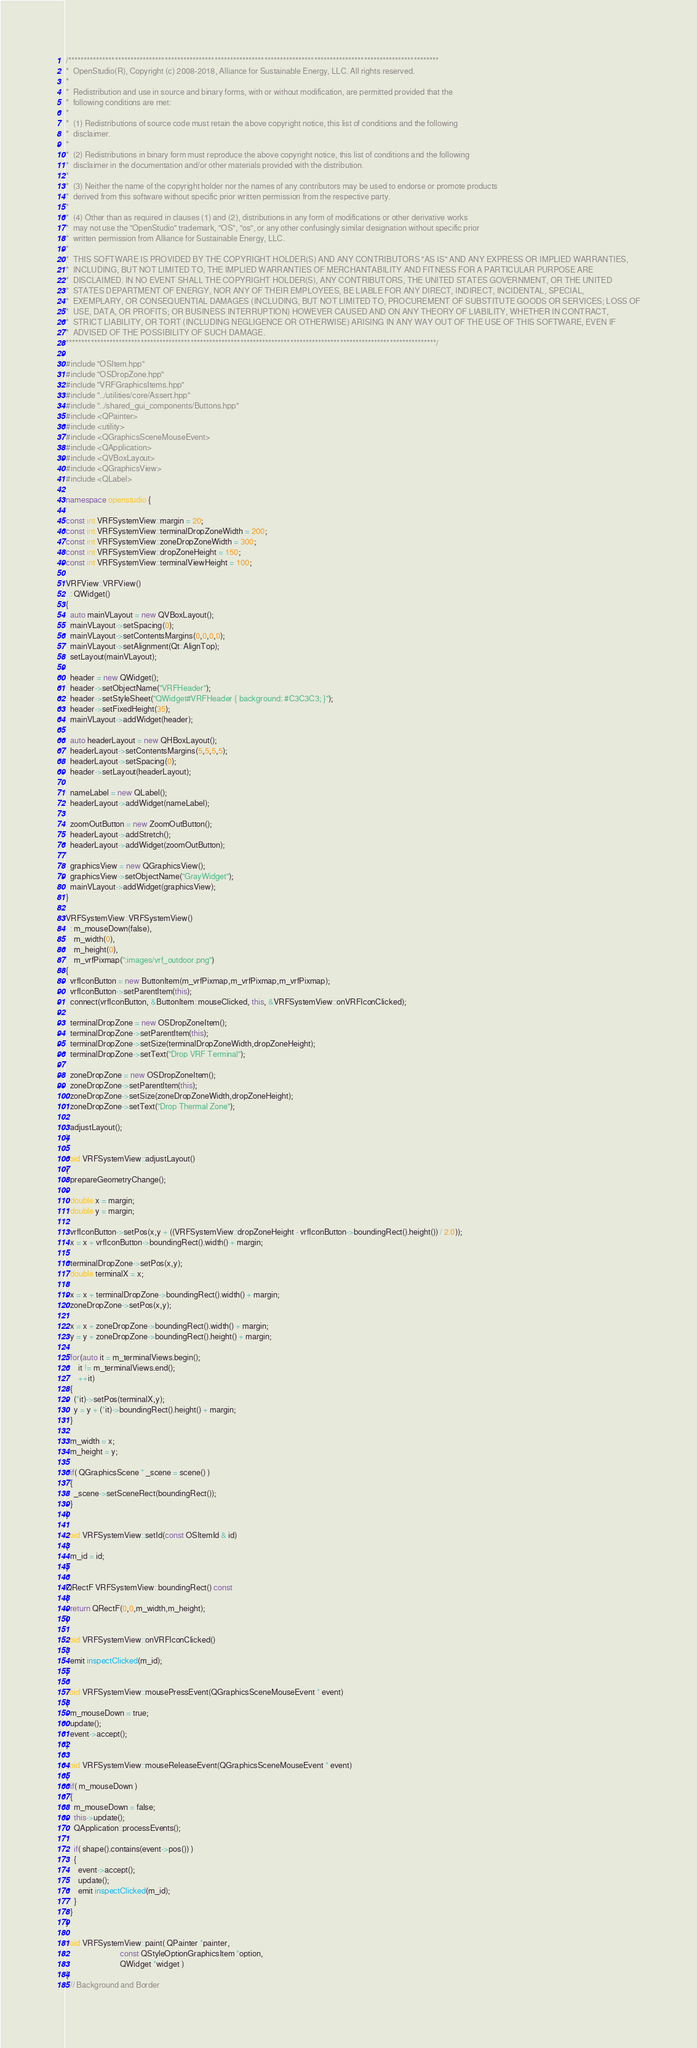Convert code to text. <code><loc_0><loc_0><loc_500><loc_500><_C++_>/***********************************************************************************************************************
*  OpenStudio(R), Copyright (c) 2008-2018, Alliance for Sustainable Energy, LLC. All rights reserved.
*
*  Redistribution and use in source and binary forms, with or without modification, are permitted provided that the
*  following conditions are met:
*
*  (1) Redistributions of source code must retain the above copyright notice, this list of conditions and the following
*  disclaimer.
*
*  (2) Redistributions in binary form must reproduce the above copyright notice, this list of conditions and the following
*  disclaimer in the documentation and/or other materials provided with the distribution.
*
*  (3) Neither the name of the copyright holder nor the names of any contributors may be used to endorse or promote products
*  derived from this software without specific prior written permission from the respective party.
*
*  (4) Other than as required in clauses (1) and (2), distributions in any form of modifications or other derivative works
*  may not use the "OpenStudio" trademark, "OS", "os", or any other confusingly similar designation without specific prior
*  written permission from Alliance for Sustainable Energy, LLC.
*
*  THIS SOFTWARE IS PROVIDED BY THE COPYRIGHT HOLDER(S) AND ANY CONTRIBUTORS "AS IS" AND ANY EXPRESS OR IMPLIED WARRANTIES,
*  INCLUDING, BUT NOT LIMITED TO, THE IMPLIED WARRANTIES OF MERCHANTABILITY AND FITNESS FOR A PARTICULAR PURPOSE ARE
*  DISCLAIMED. IN NO EVENT SHALL THE COPYRIGHT HOLDER(S), ANY CONTRIBUTORS, THE UNITED STATES GOVERNMENT, OR THE UNITED
*  STATES DEPARTMENT OF ENERGY, NOR ANY OF THEIR EMPLOYEES, BE LIABLE FOR ANY DIRECT, INDIRECT, INCIDENTAL, SPECIAL,
*  EXEMPLARY, OR CONSEQUENTIAL DAMAGES (INCLUDING, BUT NOT LIMITED TO, PROCUREMENT OF SUBSTITUTE GOODS OR SERVICES; LOSS OF
*  USE, DATA, OR PROFITS; OR BUSINESS INTERRUPTION) HOWEVER CAUSED AND ON ANY THEORY OF LIABILITY, WHETHER IN CONTRACT,
*  STRICT LIABILITY, OR TORT (INCLUDING NEGLIGENCE OR OTHERWISE) ARISING IN ANY WAY OUT OF THE USE OF THIS SOFTWARE, EVEN IF
*  ADVISED OF THE POSSIBILITY OF SUCH DAMAGE.
***********************************************************************************************************************/

#include "OSItem.hpp"
#include "OSDropZone.hpp"
#include "VRFGraphicsItems.hpp"
#include "../utilities/core/Assert.hpp"
#include "../shared_gui_components/Buttons.hpp"
#include <QPainter>
#include <utility>
#include <QGraphicsSceneMouseEvent>
#include <QApplication>
#include <QVBoxLayout>
#include <QGraphicsView>
#include <QLabel>

namespace openstudio {

const int VRFSystemView::margin = 20;
const int VRFSystemView::terminalDropZoneWidth = 200;
const int VRFSystemView::zoneDropZoneWidth = 300;
const int VRFSystemView::dropZoneHeight = 150;
const int VRFSystemView::terminalViewHeight = 100;

VRFView::VRFView()
  : QWidget()
{
  auto mainVLayout = new QVBoxLayout();
  mainVLayout->setSpacing(0);
  mainVLayout->setContentsMargins(0,0,0,0);
  mainVLayout->setAlignment(Qt::AlignTop);
  setLayout(mainVLayout);

  header = new QWidget();
  header->setObjectName("VRFHeader");
  header->setStyleSheet("QWidget#VRFHeader { background: #C3C3C3; }");
  header->setFixedHeight(35);
  mainVLayout->addWidget(header);

  auto headerLayout = new QHBoxLayout();
  headerLayout->setContentsMargins(5,5,5,5);
  headerLayout->setSpacing(0);
  header->setLayout(headerLayout);

  nameLabel = new QLabel();
  headerLayout->addWidget(nameLabel);

  zoomOutButton = new ZoomOutButton();
  headerLayout->addStretch();
  headerLayout->addWidget(zoomOutButton);

  graphicsView = new QGraphicsView();
  graphicsView->setObjectName("GrayWidget");
  mainVLayout->addWidget(graphicsView);
}

VRFSystemView::VRFSystemView()
  : m_mouseDown(false),
    m_width(0),
    m_height(0),
    m_vrfPixmap(":images/vrf_outdoor.png")
{
  vrfIconButton = new ButtonItem(m_vrfPixmap,m_vrfPixmap,m_vrfPixmap);
  vrfIconButton->setParentItem(this);
  connect(vrfIconButton, &ButtonItem::mouseClicked, this, &VRFSystemView::onVRFIconClicked);

  terminalDropZone = new OSDropZoneItem();
  terminalDropZone->setParentItem(this);
  terminalDropZone->setSize(terminalDropZoneWidth,dropZoneHeight);
  terminalDropZone->setText("Drop VRF Terminal");

  zoneDropZone = new OSDropZoneItem();
  zoneDropZone->setParentItem(this);
  zoneDropZone->setSize(zoneDropZoneWidth,dropZoneHeight);
  zoneDropZone->setText("Drop Thermal Zone");

  adjustLayout();
}

void VRFSystemView::adjustLayout()
{
  prepareGeometryChange();

  double x = margin;
  double y = margin;

  vrfIconButton->setPos(x,y + ((VRFSystemView::dropZoneHeight - vrfIconButton->boundingRect().height()) / 2.0));
  x = x + vrfIconButton->boundingRect().width() + margin;

  terminalDropZone->setPos(x,y);
  double terminalX = x;

  x = x + terminalDropZone->boundingRect().width() + margin;
  zoneDropZone->setPos(x,y);

  x = x + zoneDropZone->boundingRect().width() + margin;
  y = y + zoneDropZone->boundingRect().height() + margin;

  for(auto it = m_terminalViews.begin();
      it != m_terminalViews.end();
      ++it)
  {
    (*it)->setPos(terminalX,y);
    y = y + (*it)->boundingRect().height() + margin;
  }

  m_width = x;
  m_height = y;

  if( QGraphicsScene * _scene = scene() )
  {
    _scene->setSceneRect(boundingRect());
  }
}

void VRFSystemView::setId(const OSItemId & id)
{
  m_id = id;
}

QRectF VRFSystemView::boundingRect() const
{
  return QRectF(0,0,m_width,m_height);
}

void VRFSystemView::onVRFIconClicked()
{
  emit inspectClicked(m_id);
}

void VRFSystemView::mousePressEvent(QGraphicsSceneMouseEvent * event)
{
  m_mouseDown = true;
  update();
  event->accept();
}

void VRFSystemView::mouseReleaseEvent(QGraphicsSceneMouseEvent * event)
{
  if( m_mouseDown )
  {
    m_mouseDown = false;
    this->update();
    QApplication::processEvents();

    if( shape().contains(event->pos()) )
    {
      event->accept();
      update();
      emit inspectClicked(m_id);
    }
  }
}

void VRFSystemView::paint( QPainter *painter,
                           const QStyleOptionGraphicsItem *option,
                           QWidget *widget )
{
  // Background and Border
</code> 